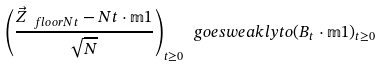Convert formula to latex. <formula><loc_0><loc_0><loc_500><loc_500>\left ( \frac { \vec { Z } _ { \ f l o o r { N t } } - N t \cdot \mathbb { m } { 1 } } { \sqrt { N } } \right ) _ { t \geq 0 } \ g o e s w e a k l y t o ( B _ { t } \cdot \mathbb { m } { 1 } ) _ { t \geq 0 }</formula> 